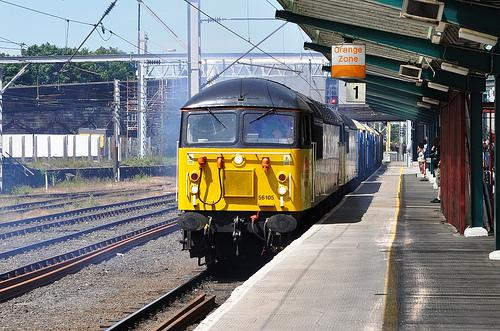Question: what color is the train?
Choices:
A. Orange.
B. Black and yellow.
C. Silver.
D. Red.
Answer with the letter. Answer: B Question: who is driving the train?
Choices:
A. The man in the head car.
B. The man looking out the window.
C. The man wearing the uniform.
D. A conductor.
Answer with the letter. Answer: D Question: when is the train going to move?
Choices:
A. After passengers board.
B. It's scheduled time.
C. When it's full.
D. When the tracks are clear.
Answer with the letter. Answer: A Question: how many train are there?
Choices:
A. One train.
B. Two trains.
C. Three trains.
D. Four trains.
Answer with the letter. Answer: A 